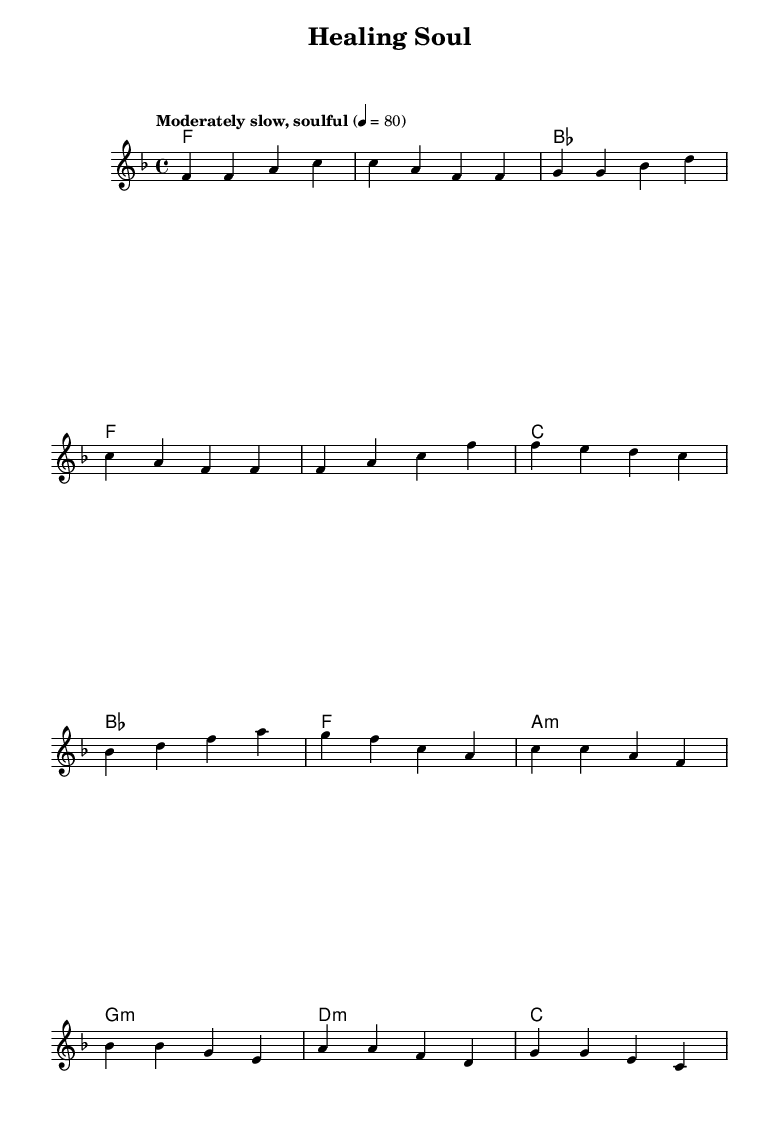What is the key signature of this music? The key signature is indicated at the beginning of the staff as F major, which has one flat (B flat).
Answer: F major What is the time signature of the piece? The time signature appears after the key signature and is 4/4, indicating four beats per measure.
Answer: 4/4 What is the tempo marking in the score? The tempo marking is written as "Moderately slow, soulful," which guides the performance speed.
Answer: Moderately slow, soulful How many measures are in the verse section? By counting the measures in the melody section labeled as "Verse," it totals four measures for this part.
Answer: Four What is the name of the chord played during the bridge? The chords during the bridge are A minor, G minor, D minor, and C; the first chord ('a:m') is A minor.
Answer: A minor Which note appears most frequently in the melody? When analyzing the melody notes, F appears in several measures and is the most repeated note.
Answer: F What genre does this piece of music belong to? Given the title "Healing Soul" and the emotional themes typically associated with the melodies and chord progressions, it aligns with the Soul genre.
Answer: Soul 